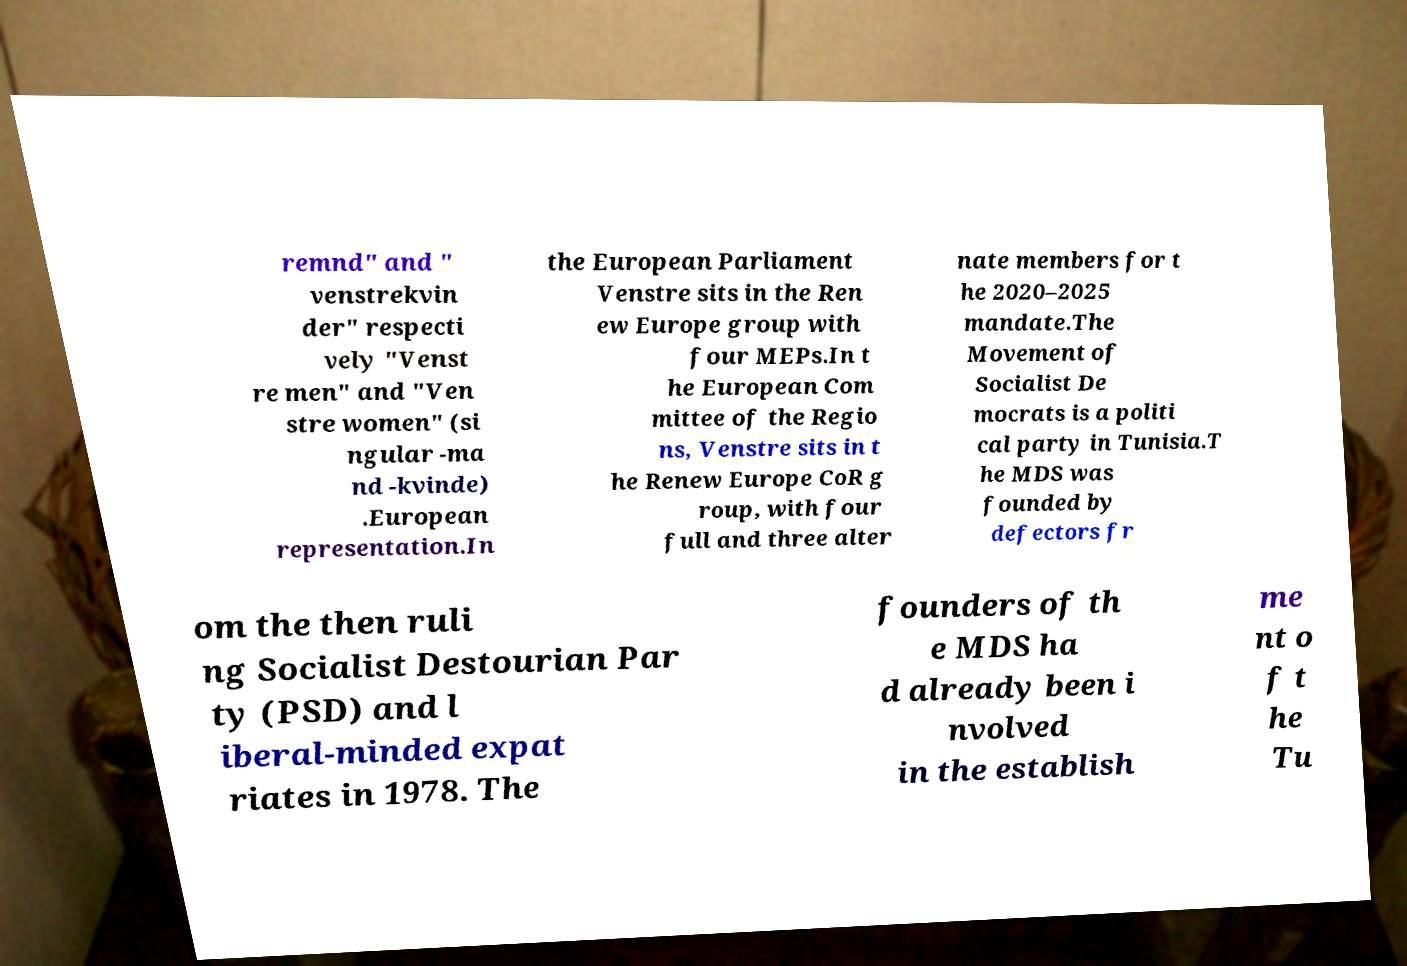I need the written content from this picture converted into text. Can you do that? remnd" and " venstrekvin der" respecti vely "Venst re men" and "Ven stre women" (si ngular -ma nd -kvinde) .European representation.In the European Parliament Venstre sits in the Ren ew Europe group with four MEPs.In t he European Com mittee of the Regio ns, Venstre sits in t he Renew Europe CoR g roup, with four full and three alter nate members for t he 2020–2025 mandate.The Movement of Socialist De mocrats is a politi cal party in Tunisia.T he MDS was founded by defectors fr om the then ruli ng Socialist Destourian Par ty (PSD) and l iberal-minded expat riates in 1978. The founders of th e MDS ha d already been i nvolved in the establish me nt o f t he Tu 